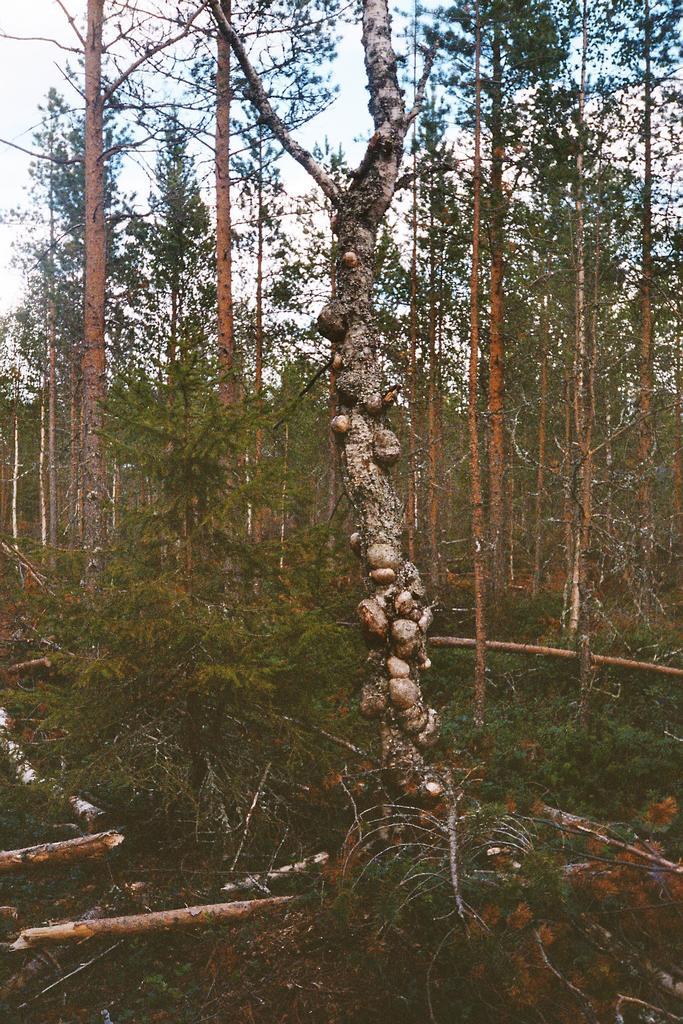Describe this image in one or two sentences. At the bottom there are cut down trees and grass on the ground. In the background there are trees and clouds in the sky. 